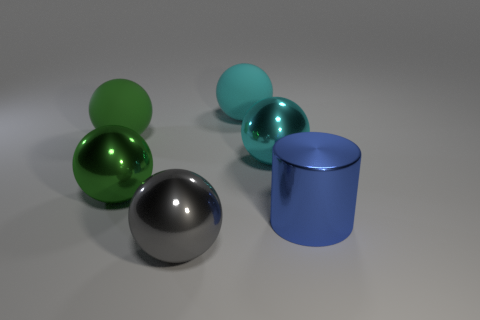Are there any green rubber things that have the same shape as the cyan rubber thing?
Offer a very short reply. Yes. The shiny cylinder that is the same size as the gray thing is what color?
Provide a succinct answer. Blue. What is the color of the large rubber thing that is to the right of the metal sphere that is in front of the large blue metallic cylinder?
Your answer should be very brief. Cyan. Do the rubber thing on the left side of the large green metal sphere and the metal cylinder have the same color?
Offer a very short reply. No. The big green thing in front of the cyan sphere that is right of the big cyan thing behind the big green matte ball is what shape?
Provide a short and direct response. Sphere. What number of big blue cylinders are on the right side of the large shiny thing right of the large cyan metal ball?
Offer a very short reply. 0. Is the large cylinder made of the same material as the gray sphere?
Keep it short and to the point. Yes. There is a big green ball behind the green metal ball in front of the cyan metal object; what number of big shiny cylinders are in front of it?
Offer a very short reply. 1. There is a sphere that is behind the green rubber sphere; what is its color?
Offer a very short reply. Cyan. What is the shape of the big green thing that is in front of the metallic ball that is behind the large green metal thing?
Your answer should be compact. Sphere. 